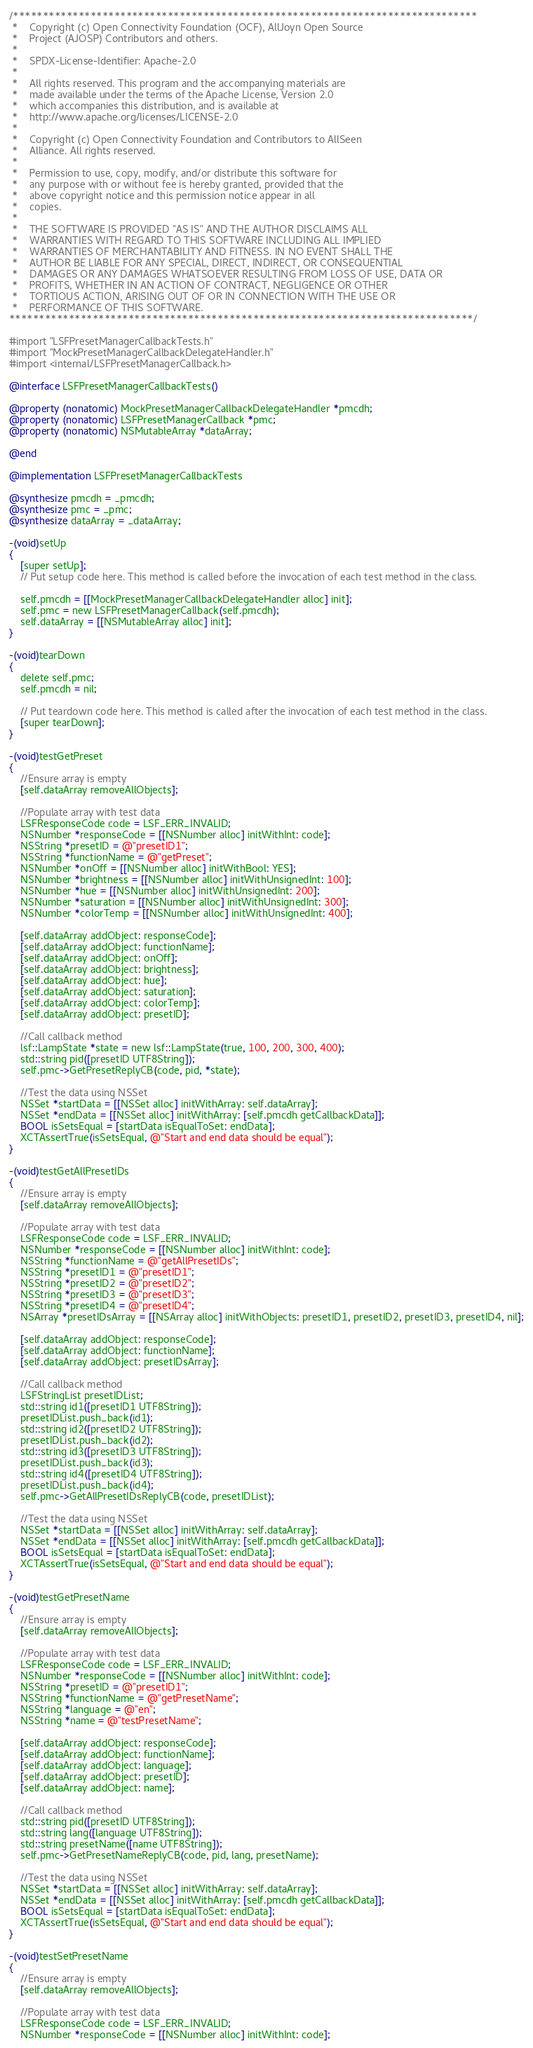Convert code to text. <code><loc_0><loc_0><loc_500><loc_500><_ObjectiveC_>/******************************************************************************
 *    Copyright (c) Open Connectivity Foundation (OCF), AllJoyn Open Source
 *    Project (AJOSP) Contributors and others.
 *    
 *    SPDX-License-Identifier: Apache-2.0
 *    
 *    All rights reserved. This program and the accompanying materials are
 *    made available under the terms of the Apache License, Version 2.0
 *    which accompanies this distribution, and is available at
 *    http://www.apache.org/licenses/LICENSE-2.0
 *    
 *    Copyright (c) Open Connectivity Foundation and Contributors to AllSeen
 *    Alliance. All rights reserved.
 *    
 *    Permission to use, copy, modify, and/or distribute this software for
 *    any purpose with or without fee is hereby granted, provided that the
 *    above copyright notice and this permission notice appear in all
 *    copies.
 *    
 *    THE SOFTWARE IS PROVIDED "AS IS" AND THE AUTHOR DISCLAIMS ALL
 *    WARRANTIES WITH REGARD TO THIS SOFTWARE INCLUDING ALL IMPLIED
 *    WARRANTIES OF MERCHANTABILITY AND FITNESS. IN NO EVENT SHALL THE
 *    AUTHOR BE LIABLE FOR ANY SPECIAL, DIRECT, INDIRECT, OR CONSEQUENTIAL
 *    DAMAGES OR ANY DAMAGES WHATSOEVER RESULTING FROM LOSS OF USE, DATA OR
 *    PROFITS, WHETHER IN AN ACTION OF CONTRACT, NEGLIGENCE OR OTHER
 *    TORTIOUS ACTION, ARISING OUT OF OR IN CONNECTION WITH THE USE OR
 *    PERFORMANCE OF THIS SOFTWARE.
******************************************************************************/

#import "LSFPresetManagerCallbackTests.h"
#import "MockPresetManagerCallbackDelegateHandler.h"
#import <internal/LSFPresetManagerCallback.h>

@interface LSFPresetManagerCallbackTests()

@property (nonatomic) MockPresetManagerCallbackDelegateHandler *pmcdh;
@property (nonatomic) LSFPresetManagerCallback *pmc;
@property (nonatomic) NSMutableArray *dataArray;

@end

@implementation LSFPresetManagerCallbackTests

@synthesize pmcdh = _pmcdh;
@synthesize pmc = _pmc;
@synthesize dataArray = _dataArray;

-(void)setUp
{
    [super setUp];
    // Put setup code here. This method is called before the invocation of each test method in the class.
    
    self.pmcdh = [[MockPresetManagerCallbackDelegateHandler alloc] init];
    self.pmc = new LSFPresetManagerCallback(self.pmcdh);
    self.dataArray = [[NSMutableArray alloc] init];
}

-(void)tearDown
{
    delete self.pmc;
    self.pmcdh = nil;
    
    // Put teardown code here. This method is called after the invocation of each test method in the class.
    [super tearDown];
}

-(void)testGetPreset
{
    //Ensure array is empty
    [self.dataArray removeAllObjects];
    
    //Populate array with test data
    LSFResponseCode code = LSF_ERR_INVALID;
    NSNumber *responseCode = [[NSNumber alloc] initWithInt: code];
    NSString *presetID = @"presetID1";
    NSString *functionName = @"getPreset";
    NSNumber *onOff = [[NSNumber alloc] initWithBool: YES];
    NSNumber *brightness = [[NSNumber alloc] initWithUnsignedInt: 100];
    NSNumber *hue = [[NSNumber alloc] initWithUnsignedInt: 200];
    NSNumber *saturation = [[NSNumber alloc] initWithUnsignedInt: 300];
    NSNumber *colorTemp = [[NSNumber alloc] initWithUnsignedInt: 400];
    
    [self.dataArray addObject: responseCode];
    [self.dataArray addObject: functionName];
    [self.dataArray addObject: onOff];
    [self.dataArray addObject: brightness];
    [self.dataArray addObject: hue];
    [self.dataArray addObject: saturation];
    [self.dataArray addObject: colorTemp];
    [self.dataArray addObject: presetID];
    
    //Call callback method
    lsf::LampState *state = new lsf::LampState(true, 100, 200, 300, 400);
    std::string pid([presetID UTF8String]);
    self.pmc->GetPresetReplyCB(code, pid, *state);
    
    //Test the data using NSSet
    NSSet *startData = [[NSSet alloc] initWithArray: self.dataArray];
    NSSet *endData = [[NSSet alloc] initWithArray: [self.pmcdh getCallbackData]];
    BOOL isSetsEqual = [startData isEqualToSet: endData];
    XCTAssertTrue(isSetsEqual, @"Start and end data should be equal");
}

-(void)testGetAllPresetIDs
{
    //Ensure array is empty
    [self.dataArray removeAllObjects];
    
    //Populate array with test data
    LSFResponseCode code = LSF_ERR_INVALID;
    NSNumber *responseCode = [[NSNumber alloc] initWithInt: code];
    NSString *functionName = @"getAllPresetIDs";
    NSString *presetID1 = @"presetID1";
    NSString *presetID2 = @"presetID2";
    NSString *presetID3 = @"presetID3";
    NSString *presetID4 = @"presetID4";
    NSArray *presetIDsArray = [[NSArray alloc] initWithObjects: presetID1, presetID2, presetID3, presetID4, nil];
    
    [self.dataArray addObject: responseCode];
    [self.dataArray addObject: functionName];
    [self.dataArray addObject: presetIDsArray];
    
    //Call callback method
    LSFStringList presetIDList;
    std::string id1([presetID1 UTF8String]);
    presetIDList.push_back(id1);
    std::string id2([presetID2 UTF8String]);
    presetIDList.push_back(id2);
    std::string id3([presetID3 UTF8String]);
    presetIDList.push_back(id3);
    std::string id4([presetID4 UTF8String]);
    presetIDList.push_back(id4);
    self.pmc->GetAllPresetIDsReplyCB(code, presetIDList);
    
    //Test the data using NSSet
    NSSet *startData = [[NSSet alloc] initWithArray: self.dataArray];
    NSSet *endData = [[NSSet alloc] initWithArray: [self.pmcdh getCallbackData]];
    BOOL isSetsEqual = [startData isEqualToSet: endData];
    XCTAssertTrue(isSetsEqual, @"Start and end data should be equal");
}

-(void)testGetPresetName
{
    //Ensure array is empty
    [self.dataArray removeAllObjects];
    
    //Populate array with test data
    LSFResponseCode code = LSF_ERR_INVALID;
    NSNumber *responseCode = [[NSNumber alloc] initWithInt: code];
    NSString *presetID = @"presetID1";
    NSString *functionName = @"getPresetName";
    NSString *language = @"en";
    NSString *name = @"testPresetName";
    
    [self.dataArray addObject: responseCode];
    [self.dataArray addObject: functionName];
    [self.dataArray addObject: language];
    [self.dataArray addObject: presetID];
    [self.dataArray addObject: name];
    
    //Call callback method
    std::string pid([presetID UTF8String]);
    std::string lang([language UTF8String]);
    std::string presetName([name UTF8String]);
    self.pmc->GetPresetNameReplyCB(code, pid, lang, presetName);
    
    //Test the data using NSSet
    NSSet *startData = [[NSSet alloc] initWithArray: self.dataArray];
    NSSet *endData = [[NSSet alloc] initWithArray: [self.pmcdh getCallbackData]];
    BOOL isSetsEqual = [startData isEqualToSet: endData];
    XCTAssertTrue(isSetsEqual, @"Start and end data should be equal");
}

-(void)testSetPresetName
{
    //Ensure array is empty
    [self.dataArray removeAllObjects];
    
    //Populate array with test data
    LSFResponseCode code = LSF_ERR_INVALID;
    NSNumber *responseCode = [[NSNumber alloc] initWithInt: code];</code> 